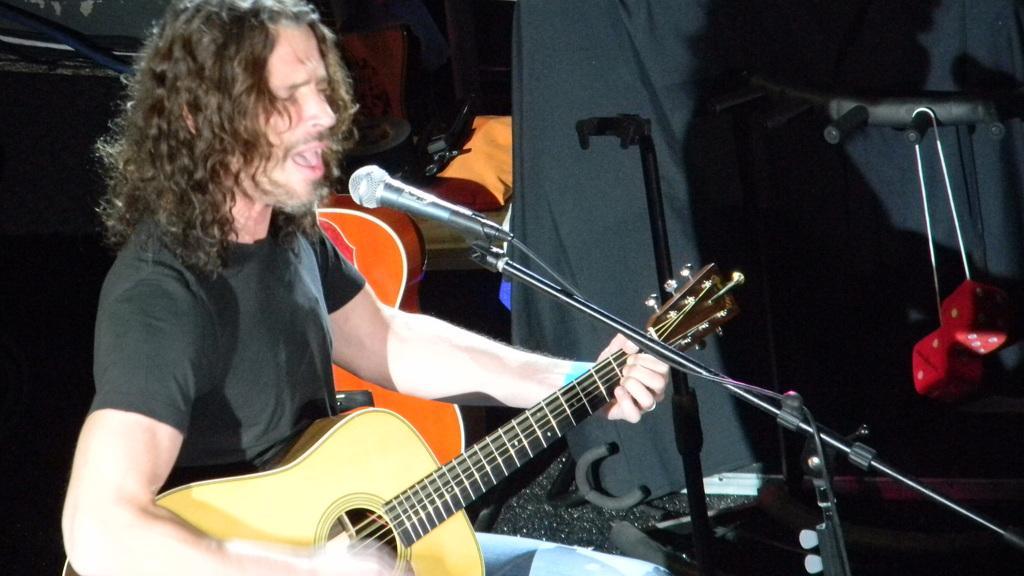Describe this image in one or two sentences. In the picture there is a man playing guitar and singing on mic. 